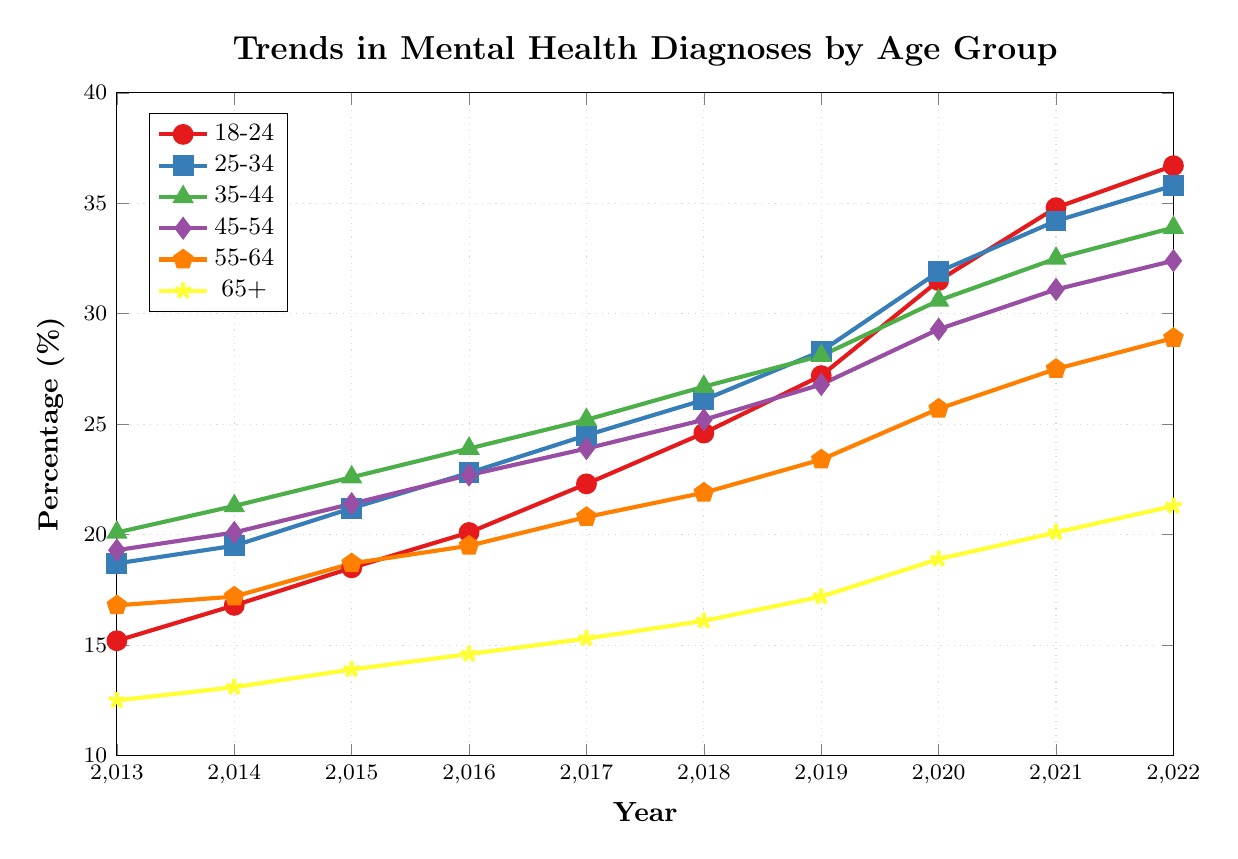What's the general trend in mental health diagnoses for the 18-24 age group from 2013 to 2022? The line for the 18-24 age group shows a steady increase from 2013 to 2022. Starting at 15.2% in 2013 and rising to 36.7% in 2022.
Answer: Steady increase Which age group had the highest percentage of mental health diagnoses in 2022? By examining the end of the lines in 2022, the 18-24 age group, which finishes at 36.7%, has the highest percentage.
Answer: 18-24 How does the percentage of mental health diagnoses for the 55-64 age group in 2022 compare to that in 2013? The 55-64 age group started at 16.8% in 2013 and increased to 28.9% in 2022. This shows a clear increase.
Answer: Increased Which age group shows the least change in percentage from 2013 to 2022? By reviewing the endpoints of the line series, the 65+ age group changes from 12.5% in 2013 to 21.3% in 2022, which is the smallest increase.
Answer: 65+ What is the percentage difference in mental health diagnoses between the 25-34 and 35-44 age groups in 2020? In 2020, the percentage for the 25-34 age group is 31.9%, and for the 35-44 age group, it is 30.6%. The difference is 31.9% - 30.6% = 1.3%.
Answer: 1.3% What visual element is used to represent the 45-54 age group, and what is its value in 2017? The 45-54 age group is represented by a purple diamond marker, and its value in 2017 is 23.9%.
Answer: Purple diamond, 23.9% Between which consecutive years did the 18-24 age group see the highest increase in percentage? Observing the values, the largest increase for the 18-24 age group is between 2019 (27.2%) and 2020 (31.5%), which is an increase of 4.3%.
Answer: 2019-2020 What is the average percentage of mental health diagnoses for the 65+ age group over the decade? Summing the percentages from 2013 to 2022 for the 65+ group: (12.5 + 13.1 + 13.9 + 14.6 + 15.3 + 16.1 + 17.2 + 18.9 + 20.1 + 21.3) = 163.0%, then dividing by 10 years gives an average: 163.0 / 10 = 16.3%.
Answer: 16.3% Which age group shows a crossing trendline with another, and in what year does this happen? The trendlines of the 25-34 and 35-44 age groups cross around 2021, where both percentages are very close (34.2% for 25-34 and 32.5% for 35-44).
Answer: 25-34 and 35-44, 2021 